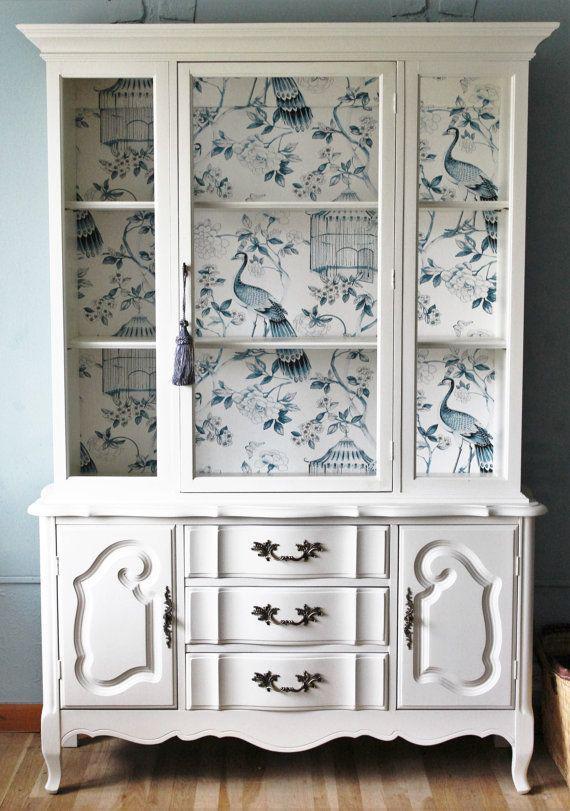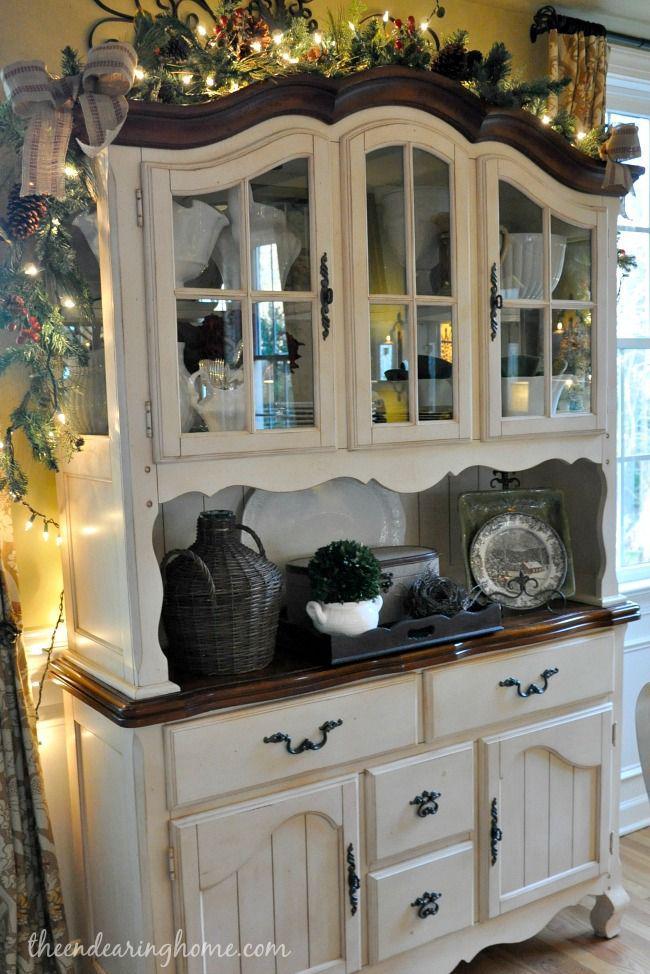The first image is the image on the left, the second image is the image on the right. Assess this claim about the two images: "There are gray diningroom hutches". Correct or not? Answer yes or no. No. The first image is the image on the left, the second image is the image on the right. Given the left and right images, does the statement "One image features a cabinet with a curved top detail instead of a completely flat top." hold true? Answer yes or no. Yes. 